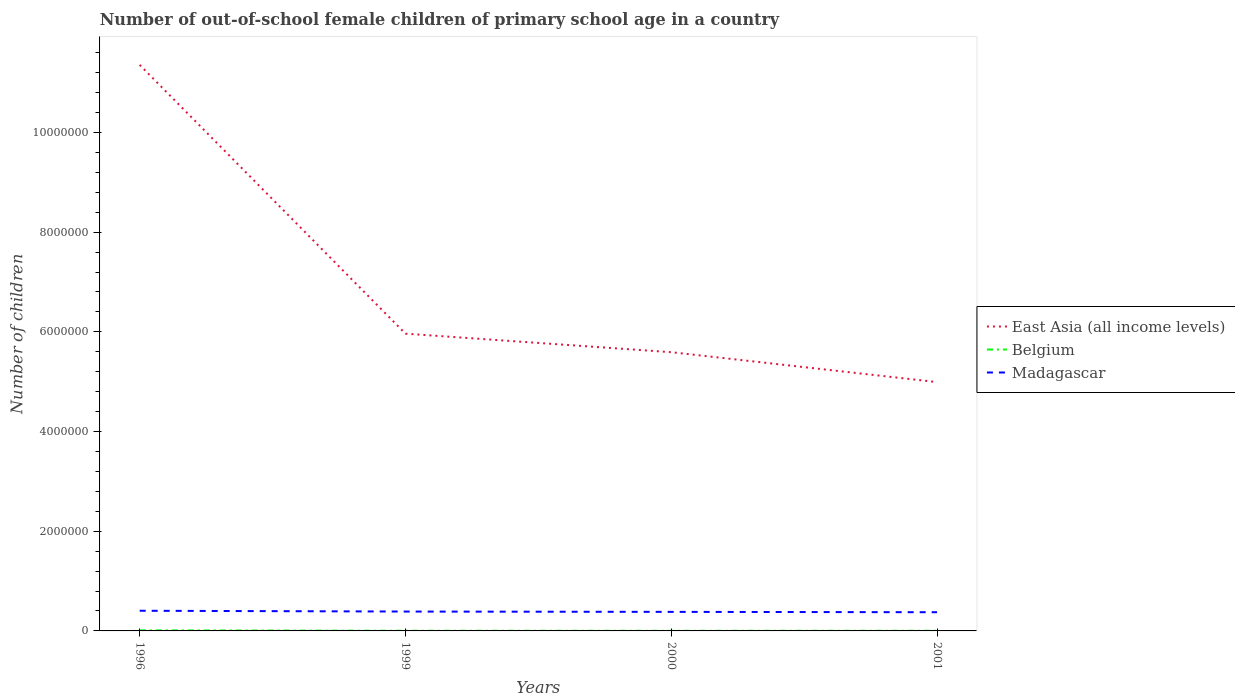Does the line corresponding to Belgium intersect with the line corresponding to Madagascar?
Offer a terse response. No. Is the number of lines equal to the number of legend labels?
Provide a succinct answer. Yes. Across all years, what is the maximum number of out-of-school female children in East Asia (all income levels)?
Your response must be concise. 4.99e+06. In which year was the number of out-of-school female children in Belgium maximum?
Provide a short and direct response. 2000. What is the total number of out-of-school female children in Belgium in the graph?
Your answer should be very brief. 8929. What is the difference between the highest and the second highest number of out-of-school female children in Belgium?
Give a very brief answer. 8929. What is the difference between the highest and the lowest number of out-of-school female children in Belgium?
Ensure brevity in your answer.  1. How many lines are there?
Give a very brief answer. 3. How many years are there in the graph?
Offer a terse response. 4. What is the difference between two consecutive major ticks on the Y-axis?
Your answer should be compact. 2.00e+06. How many legend labels are there?
Your response must be concise. 3. How are the legend labels stacked?
Offer a very short reply. Vertical. What is the title of the graph?
Provide a short and direct response. Number of out-of-school female children of primary school age in a country. What is the label or title of the Y-axis?
Your answer should be compact. Number of children. What is the Number of children of East Asia (all income levels) in 1996?
Keep it short and to the point. 1.14e+07. What is the Number of children of Belgium in 1996?
Offer a terse response. 1.15e+04. What is the Number of children in Madagascar in 1996?
Offer a very short reply. 4.05e+05. What is the Number of children of East Asia (all income levels) in 1999?
Offer a very short reply. 5.96e+06. What is the Number of children of Belgium in 1999?
Provide a succinct answer. 3430. What is the Number of children in Madagascar in 1999?
Ensure brevity in your answer.  3.89e+05. What is the Number of children of East Asia (all income levels) in 2000?
Offer a very short reply. 5.59e+06. What is the Number of children of Belgium in 2000?
Your answer should be very brief. 2536. What is the Number of children in Madagascar in 2000?
Offer a very short reply. 3.82e+05. What is the Number of children of East Asia (all income levels) in 2001?
Provide a succinct answer. 4.99e+06. What is the Number of children of Belgium in 2001?
Your answer should be very brief. 3006. What is the Number of children in Madagascar in 2001?
Provide a short and direct response. 3.75e+05. Across all years, what is the maximum Number of children in East Asia (all income levels)?
Provide a short and direct response. 1.14e+07. Across all years, what is the maximum Number of children of Belgium?
Make the answer very short. 1.15e+04. Across all years, what is the maximum Number of children of Madagascar?
Your answer should be compact. 4.05e+05. Across all years, what is the minimum Number of children in East Asia (all income levels)?
Offer a terse response. 4.99e+06. Across all years, what is the minimum Number of children of Belgium?
Give a very brief answer. 2536. Across all years, what is the minimum Number of children of Madagascar?
Offer a very short reply. 3.75e+05. What is the total Number of children of East Asia (all income levels) in the graph?
Keep it short and to the point. 2.79e+07. What is the total Number of children in Belgium in the graph?
Offer a very short reply. 2.04e+04. What is the total Number of children in Madagascar in the graph?
Offer a very short reply. 1.55e+06. What is the difference between the Number of children of East Asia (all income levels) in 1996 and that in 1999?
Make the answer very short. 5.39e+06. What is the difference between the Number of children in Belgium in 1996 and that in 1999?
Your answer should be very brief. 8035. What is the difference between the Number of children of Madagascar in 1996 and that in 1999?
Give a very brief answer. 1.58e+04. What is the difference between the Number of children of East Asia (all income levels) in 1996 and that in 2000?
Keep it short and to the point. 5.76e+06. What is the difference between the Number of children of Belgium in 1996 and that in 2000?
Your answer should be compact. 8929. What is the difference between the Number of children of Madagascar in 1996 and that in 2000?
Make the answer very short. 2.24e+04. What is the difference between the Number of children in East Asia (all income levels) in 1996 and that in 2001?
Your answer should be very brief. 6.36e+06. What is the difference between the Number of children in Belgium in 1996 and that in 2001?
Offer a terse response. 8459. What is the difference between the Number of children in Madagascar in 1996 and that in 2001?
Keep it short and to the point. 2.94e+04. What is the difference between the Number of children of East Asia (all income levels) in 1999 and that in 2000?
Keep it short and to the point. 3.72e+05. What is the difference between the Number of children of Belgium in 1999 and that in 2000?
Keep it short and to the point. 894. What is the difference between the Number of children of Madagascar in 1999 and that in 2000?
Keep it short and to the point. 6523. What is the difference between the Number of children of East Asia (all income levels) in 1999 and that in 2001?
Offer a very short reply. 9.72e+05. What is the difference between the Number of children in Belgium in 1999 and that in 2001?
Your answer should be compact. 424. What is the difference between the Number of children in Madagascar in 1999 and that in 2001?
Your response must be concise. 1.35e+04. What is the difference between the Number of children in East Asia (all income levels) in 2000 and that in 2001?
Provide a succinct answer. 6.00e+05. What is the difference between the Number of children of Belgium in 2000 and that in 2001?
Give a very brief answer. -470. What is the difference between the Number of children in Madagascar in 2000 and that in 2001?
Make the answer very short. 7022. What is the difference between the Number of children in East Asia (all income levels) in 1996 and the Number of children in Belgium in 1999?
Your response must be concise. 1.14e+07. What is the difference between the Number of children of East Asia (all income levels) in 1996 and the Number of children of Madagascar in 1999?
Provide a succinct answer. 1.10e+07. What is the difference between the Number of children of Belgium in 1996 and the Number of children of Madagascar in 1999?
Your answer should be very brief. -3.77e+05. What is the difference between the Number of children in East Asia (all income levels) in 1996 and the Number of children in Belgium in 2000?
Your response must be concise. 1.14e+07. What is the difference between the Number of children of East Asia (all income levels) in 1996 and the Number of children of Madagascar in 2000?
Your answer should be very brief. 1.10e+07. What is the difference between the Number of children of Belgium in 1996 and the Number of children of Madagascar in 2000?
Offer a very short reply. -3.71e+05. What is the difference between the Number of children of East Asia (all income levels) in 1996 and the Number of children of Belgium in 2001?
Give a very brief answer. 1.14e+07. What is the difference between the Number of children in East Asia (all income levels) in 1996 and the Number of children in Madagascar in 2001?
Your answer should be compact. 1.10e+07. What is the difference between the Number of children in Belgium in 1996 and the Number of children in Madagascar in 2001?
Provide a short and direct response. -3.64e+05. What is the difference between the Number of children of East Asia (all income levels) in 1999 and the Number of children of Belgium in 2000?
Provide a succinct answer. 5.96e+06. What is the difference between the Number of children of East Asia (all income levels) in 1999 and the Number of children of Madagascar in 2000?
Your response must be concise. 5.58e+06. What is the difference between the Number of children in Belgium in 1999 and the Number of children in Madagascar in 2000?
Give a very brief answer. -3.79e+05. What is the difference between the Number of children in East Asia (all income levels) in 1999 and the Number of children in Belgium in 2001?
Offer a very short reply. 5.96e+06. What is the difference between the Number of children of East Asia (all income levels) in 1999 and the Number of children of Madagascar in 2001?
Provide a succinct answer. 5.59e+06. What is the difference between the Number of children in Belgium in 1999 and the Number of children in Madagascar in 2001?
Offer a very short reply. -3.72e+05. What is the difference between the Number of children in East Asia (all income levels) in 2000 and the Number of children in Belgium in 2001?
Ensure brevity in your answer.  5.59e+06. What is the difference between the Number of children in East Asia (all income levels) in 2000 and the Number of children in Madagascar in 2001?
Your answer should be compact. 5.22e+06. What is the difference between the Number of children in Belgium in 2000 and the Number of children in Madagascar in 2001?
Make the answer very short. -3.73e+05. What is the average Number of children in East Asia (all income levels) per year?
Make the answer very short. 6.98e+06. What is the average Number of children of Belgium per year?
Keep it short and to the point. 5109.25. What is the average Number of children in Madagascar per year?
Keep it short and to the point. 3.88e+05. In the year 1996, what is the difference between the Number of children in East Asia (all income levels) and Number of children in Belgium?
Offer a very short reply. 1.13e+07. In the year 1996, what is the difference between the Number of children in East Asia (all income levels) and Number of children in Madagascar?
Your answer should be very brief. 1.10e+07. In the year 1996, what is the difference between the Number of children of Belgium and Number of children of Madagascar?
Keep it short and to the point. -3.93e+05. In the year 1999, what is the difference between the Number of children of East Asia (all income levels) and Number of children of Belgium?
Offer a very short reply. 5.96e+06. In the year 1999, what is the difference between the Number of children in East Asia (all income levels) and Number of children in Madagascar?
Your answer should be very brief. 5.57e+06. In the year 1999, what is the difference between the Number of children of Belgium and Number of children of Madagascar?
Provide a succinct answer. -3.85e+05. In the year 2000, what is the difference between the Number of children in East Asia (all income levels) and Number of children in Belgium?
Provide a succinct answer. 5.59e+06. In the year 2000, what is the difference between the Number of children in East Asia (all income levels) and Number of children in Madagascar?
Ensure brevity in your answer.  5.21e+06. In the year 2000, what is the difference between the Number of children in Belgium and Number of children in Madagascar?
Ensure brevity in your answer.  -3.80e+05. In the year 2001, what is the difference between the Number of children of East Asia (all income levels) and Number of children of Belgium?
Offer a very short reply. 4.99e+06. In the year 2001, what is the difference between the Number of children in East Asia (all income levels) and Number of children in Madagascar?
Your answer should be compact. 4.62e+06. In the year 2001, what is the difference between the Number of children of Belgium and Number of children of Madagascar?
Your answer should be very brief. -3.72e+05. What is the ratio of the Number of children of East Asia (all income levels) in 1996 to that in 1999?
Offer a very short reply. 1.9. What is the ratio of the Number of children of Belgium in 1996 to that in 1999?
Your answer should be very brief. 3.34. What is the ratio of the Number of children of Madagascar in 1996 to that in 1999?
Make the answer very short. 1.04. What is the ratio of the Number of children of East Asia (all income levels) in 1996 to that in 2000?
Make the answer very short. 2.03. What is the ratio of the Number of children in Belgium in 1996 to that in 2000?
Offer a very short reply. 4.52. What is the ratio of the Number of children in Madagascar in 1996 to that in 2000?
Give a very brief answer. 1.06. What is the ratio of the Number of children of East Asia (all income levels) in 1996 to that in 2001?
Offer a very short reply. 2.27. What is the ratio of the Number of children of Belgium in 1996 to that in 2001?
Give a very brief answer. 3.81. What is the ratio of the Number of children of Madagascar in 1996 to that in 2001?
Offer a terse response. 1.08. What is the ratio of the Number of children in East Asia (all income levels) in 1999 to that in 2000?
Keep it short and to the point. 1.07. What is the ratio of the Number of children in Belgium in 1999 to that in 2000?
Your answer should be compact. 1.35. What is the ratio of the Number of children of Madagascar in 1999 to that in 2000?
Provide a succinct answer. 1.02. What is the ratio of the Number of children of East Asia (all income levels) in 1999 to that in 2001?
Your answer should be very brief. 1.19. What is the ratio of the Number of children in Belgium in 1999 to that in 2001?
Offer a terse response. 1.14. What is the ratio of the Number of children in Madagascar in 1999 to that in 2001?
Keep it short and to the point. 1.04. What is the ratio of the Number of children in East Asia (all income levels) in 2000 to that in 2001?
Keep it short and to the point. 1.12. What is the ratio of the Number of children in Belgium in 2000 to that in 2001?
Your answer should be very brief. 0.84. What is the ratio of the Number of children of Madagascar in 2000 to that in 2001?
Your answer should be very brief. 1.02. What is the difference between the highest and the second highest Number of children of East Asia (all income levels)?
Give a very brief answer. 5.39e+06. What is the difference between the highest and the second highest Number of children of Belgium?
Provide a short and direct response. 8035. What is the difference between the highest and the second highest Number of children of Madagascar?
Your answer should be very brief. 1.58e+04. What is the difference between the highest and the lowest Number of children in East Asia (all income levels)?
Your answer should be compact. 6.36e+06. What is the difference between the highest and the lowest Number of children of Belgium?
Your answer should be very brief. 8929. What is the difference between the highest and the lowest Number of children of Madagascar?
Offer a very short reply. 2.94e+04. 